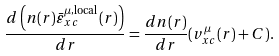Convert formula to latex. <formula><loc_0><loc_0><loc_500><loc_500>\frac { d \left ( n ( r ) \bar { \varepsilon } _ { x c } ^ { \mu , \text {local} } ( r ) \right ) } { d r } = \frac { d n ( r ) } { d r } ( v _ { x c } ^ { \mu } ( r ) + C ) .</formula> 